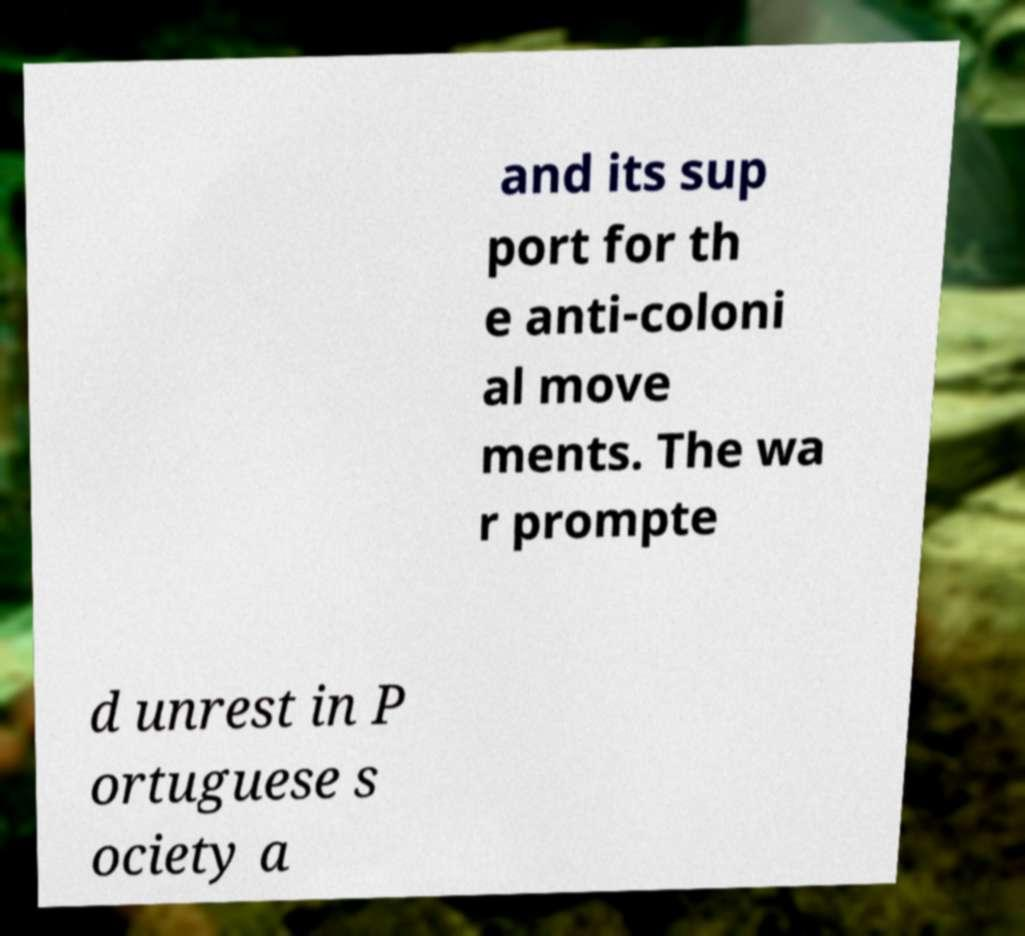Could you extract and type out the text from this image? and its sup port for th e anti-coloni al move ments. The wa r prompte d unrest in P ortuguese s ociety a 